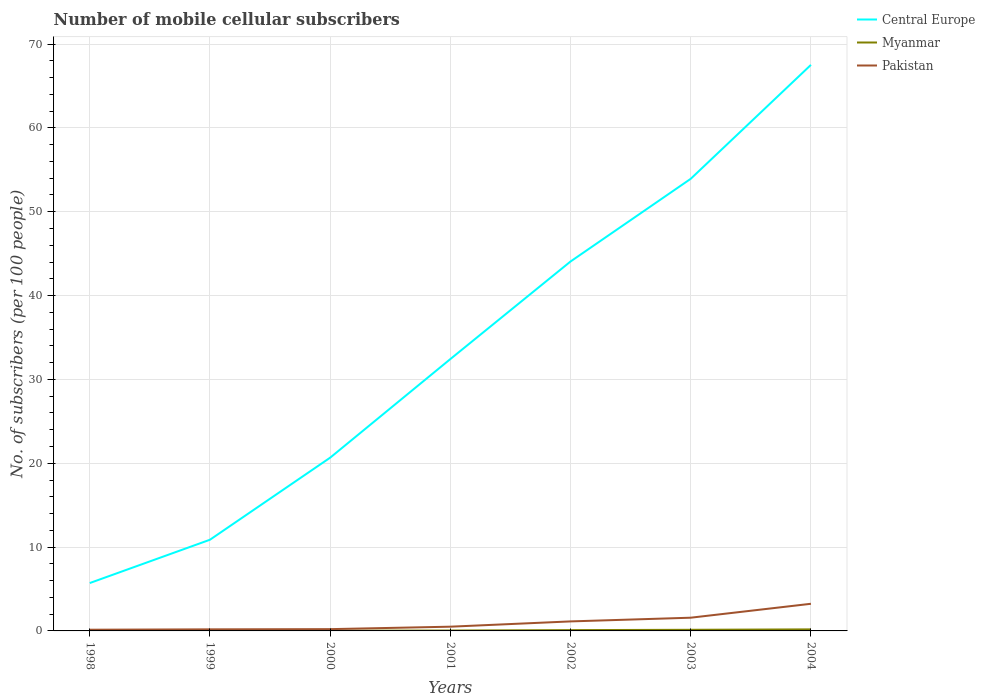Across all years, what is the maximum number of mobile cellular subscribers in Central Europe?
Offer a very short reply. 5.71. In which year was the number of mobile cellular subscribers in Pakistan maximum?
Ensure brevity in your answer.  1998. What is the total number of mobile cellular subscribers in Central Europe in the graph?
Offer a very short reply. -21.55. What is the difference between the highest and the second highest number of mobile cellular subscribers in Central Europe?
Provide a short and direct response. 61.81. Does the graph contain any zero values?
Offer a terse response. No. Does the graph contain grids?
Ensure brevity in your answer.  Yes. Where does the legend appear in the graph?
Provide a succinct answer. Top right. What is the title of the graph?
Your answer should be compact. Number of mobile cellular subscribers. Does "Czech Republic" appear as one of the legend labels in the graph?
Ensure brevity in your answer.  No. What is the label or title of the X-axis?
Ensure brevity in your answer.  Years. What is the label or title of the Y-axis?
Ensure brevity in your answer.  No. of subscribers (per 100 people). What is the No. of subscribers (per 100 people) of Central Europe in 1998?
Your answer should be very brief. 5.71. What is the No. of subscribers (per 100 people) of Myanmar in 1998?
Make the answer very short. 0.02. What is the No. of subscribers (per 100 people) of Pakistan in 1998?
Your answer should be compact. 0.14. What is the No. of subscribers (per 100 people) of Central Europe in 1999?
Your response must be concise. 10.88. What is the No. of subscribers (per 100 people) in Myanmar in 1999?
Offer a terse response. 0.02. What is the No. of subscribers (per 100 people) of Pakistan in 1999?
Make the answer very short. 0.19. What is the No. of subscribers (per 100 people) in Central Europe in 2000?
Offer a very short reply. 20.66. What is the No. of subscribers (per 100 people) in Myanmar in 2000?
Ensure brevity in your answer.  0.03. What is the No. of subscribers (per 100 people) of Pakistan in 2000?
Give a very brief answer. 0.21. What is the No. of subscribers (per 100 people) of Central Europe in 2001?
Give a very brief answer. 32.43. What is the No. of subscribers (per 100 people) in Myanmar in 2001?
Give a very brief answer. 0.05. What is the No. of subscribers (per 100 people) in Pakistan in 2001?
Your answer should be compact. 0.51. What is the No. of subscribers (per 100 people) of Central Europe in 2002?
Make the answer very short. 44.07. What is the No. of subscribers (per 100 people) of Myanmar in 2002?
Offer a terse response. 0.1. What is the No. of subscribers (per 100 people) of Pakistan in 2002?
Your answer should be compact. 1.13. What is the No. of subscribers (per 100 people) of Central Europe in 2003?
Give a very brief answer. 53.93. What is the No. of subscribers (per 100 people) of Myanmar in 2003?
Your answer should be compact. 0.13. What is the No. of subscribers (per 100 people) of Pakistan in 2003?
Keep it short and to the point. 1.58. What is the No. of subscribers (per 100 people) in Central Europe in 2004?
Make the answer very short. 67.52. What is the No. of subscribers (per 100 people) in Myanmar in 2004?
Make the answer very short. 0.19. What is the No. of subscribers (per 100 people) of Pakistan in 2004?
Ensure brevity in your answer.  3.24. Across all years, what is the maximum No. of subscribers (per 100 people) of Central Europe?
Offer a very short reply. 67.52. Across all years, what is the maximum No. of subscribers (per 100 people) in Myanmar?
Ensure brevity in your answer.  0.19. Across all years, what is the maximum No. of subscribers (per 100 people) in Pakistan?
Give a very brief answer. 3.24. Across all years, what is the minimum No. of subscribers (per 100 people) of Central Europe?
Keep it short and to the point. 5.71. Across all years, what is the minimum No. of subscribers (per 100 people) in Myanmar?
Keep it short and to the point. 0.02. Across all years, what is the minimum No. of subscribers (per 100 people) of Pakistan?
Make the answer very short. 0.14. What is the total No. of subscribers (per 100 people) of Central Europe in the graph?
Offer a terse response. 235.2. What is the total No. of subscribers (per 100 people) of Myanmar in the graph?
Your answer should be very brief. 0.53. What is the total No. of subscribers (per 100 people) in Pakistan in the graph?
Make the answer very short. 7. What is the difference between the No. of subscribers (per 100 people) of Central Europe in 1998 and that in 1999?
Provide a short and direct response. -5.17. What is the difference between the No. of subscribers (per 100 people) in Myanmar in 1998 and that in 1999?
Give a very brief answer. -0.01. What is the difference between the No. of subscribers (per 100 people) of Pakistan in 1998 and that in 1999?
Provide a short and direct response. -0.05. What is the difference between the No. of subscribers (per 100 people) in Central Europe in 1998 and that in 2000?
Offer a terse response. -14.95. What is the difference between the No. of subscribers (per 100 people) in Myanmar in 1998 and that in 2000?
Make the answer very short. -0.01. What is the difference between the No. of subscribers (per 100 people) in Pakistan in 1998 and that in 2000?
Provide a succinct answer. -0.07. What is the difference between the No. of subscribers (per 100 people) of Central Europe in 1998 and that in 2001?
Make the answer very short. -26.72. What is the difference between the No. of subscribers (per 100 people) in Myanmar in 1998 and that in 2001?
Your response must be concise. -0.03. What is the difference between the No. of subscribers (per 100 people) of Pakistan in 1998 and that in 2001?
Provide a short and direct response. -0.36. What is the difference between the No. of subscribers (per 100 people) in Central Europe in 1998 and that in 2002?
Provide a short and direct response. -38.36. What is the difference between the No. of subscribers (per 100 people) of Myanmar in 1998 and that in 2002?
Your answer should be very brief. -0.08. What is the difference between the No. of subscribers (per 100 people) of Pakistan in 1998 and that in 2002?
Your answer should be compact. -0.99. What is the difference between the No. of subscribers (per 100 people) of Central Europe in 1998 and that in 2003?
Offer a terse response. -48.22. What is the difference between the No. of subscribers (per 100 people) in Myanmar in 1998 and that in 2003?
Provide a succinct answer. -0.12. What is the difference between the No. of subscribers (per 100 people) of Pakistan in 1998 and that in 2003?
Your answer should be very brief. -1.43. What is the difference between the No. of subscribers (per 100 people) of Central Europe in 1998 and that in 2004?
Provide a succinct answer. -61.81. What is the difference between the No. of subscribers (per 100 people) in Myanmar in 1998 and that in 2004?
Your response must be concise. -0.17. What is the difference between the No. of subscribers (per 100 people) of Pakistan in 1998 and that in 2004?
Provide a short and direct response. -3.09. What is the difference between the No. of subscribers (per 100 people) in Central Europe in 1999 and that in 2000?
Ensure brevity in your answer.  -9.79. What is the difference between the No. of subscribers (per 100 people) of Myanmar in 1999 and that in 2000?
Your answer should be compact. -0. What is the difference between the No. of subscribers (per 100 people) of Pakistan in 1999 and that in 2000?
Keep it short and to the point. -0.02. What is the difference between the No. of subscribers (per 100 people) of Central Europe in 1999 and that in 2001?
Offer a terse response. -21.55. What is the difference between the No. of subscribers (per 100 people) of Myanmar in 1999 and that in 2001?
Your response must be concise. -0.02. What is the difference between the No. of subscribers (per 100 people) of Pakistan in 1999 and that in 2001?
Provide a succinct answer. -0.32. What is the difference between the No. of subscribers (per 100 people) in Central Europe in 1999 and that in 2002?
Give a very brief answer. -33.19. What is the difference between the No. of subscribers (per 100 people) of Myanmar in 1999 and that in 2002?
Ensure brevity in your answer.  -0.07. What is the difference between the No. of subscribers (per 100 people) of Pakistan in 1999 and that in 2002?
Keep it short and to the point. -0.95. What is the difference between the No. of subscribers (per 100 people) in Central Europe in 1999 and that in 2003?
Keep it short and to the point. -43.05. What is the difference between the No. of subscribers (per 100 people) of Myanmar in 1999 and that in 2003?
Offer a terse response. -0.11. What is the difference between the No. of subscribers (per 100 people) of Pakistan in 1999 and that in 2003?
Provide a succinct answer. -1.39. What is the difference between the No. of subscribers (per 100 people) of Central Europe in 1999 and that in 2004?
Provide a succinct answer. -56.64. What is the difference between the No. of subscribers (per 100 people) in Myanmar in 1999 and that in 2004?
Provide a succinct answer. -0.16. What is the difference between the No. of subscribers (per 100 people) of Pakistan in 1999 and that in 2004?
Ensure brevity in your answer.  -3.05. What is the difference between the No. of subscribers (per 100 people) in Central Europe in 2000 and that in 2001?
Provide a short and direct response. -11.76. What is the difference between the No. of subscribers (per 100 people) in Myanmar in 2000 and that in 2001?
Provide a succinct answer. -0.02. What is the difference between the No. of subscribers (per 100 people) in Pakistan in 2000 and that in 2001?
Ensure brevity in your answer.  -0.29. What is the difference between the No. of subscribers (per 100 people) of Central Europe in 2000 and that in 2002?
Your answer should be compact. -23.4. What is the difference between the No. of subscribers (per 100 people) of Myanmar in 2000 and that in 2002?
Ensure brevity in your answer.  -0.07. What is the difference between the No. of subscribers (per 100 people) of Pakistan in 2000 and that in 2002?
Offer a terse response. -0.92. What is the difference between the No. of subscribers (per 100 people) in Central Europe in 2000 and that in 2003?
Offer a terse response. -33.27. What is the difference between the No. of subscribers (per 100 people) of Myanmar in 2000 and that in 2003?
Ensure brevity in your answer.  -0.11. What is the difference between the No. of subscribers (per 100 people) of Pakistan in 2000 and that in 2003?
Your response must be concise. -1.36. What is the difference between the No. of subscribers (per 100 people) of Central Europe in 2000 and that in 2004?
Your answer should be very brief. -46.85. What is the difference between the No. of subscribers (per 100 people) of Myanmar in 2000 and that in 2004?
Your answer should be very brief. -0.16. What is the difference between the No. of subscribers (per 100 people) of Pakistan in 2000 and that in 2004?
Give a very brief answer. -3.02. What is the difference between the No. of subscribers (per 100 people) in Central Europe in 2001 and that in 2002?
Make the answer very short. -11.64. What is the difference between the No. of subscribers (per 100 people) of Myanmar in 2001 and that in 2002?
Make the answer very short. -0.05. What is the difference between the No. of subscribers (per 100 people) of Pakistan in 2001 and that in 2002?
Keep it short and to the point. -0.63. What is the difference between the No. of subscribers (per 100 people) in Central Europe in 2001 and that in 2003?
Your response must be concise. -21.5. What is the difference between the No. of subscribers (per 100 people) in Myanmar in 2001 and that in 2003?
Keep it short and to the point. -0.09. What is the difference between the No. of subscribers (per 100 people) in Pakistan in 2001 and that in 2003?
Offer a very short reply. -1.07. What is the difference between the No. of subscribers (per 100 people) of Central Europe in 2001 and that in 2004?
Offer a terse response. -35.09. What is the difference between the No. of subscribers (per 100 people) in Myanmar in 2001 and that in 2004?
Your answer should be compact. -0.14. What is the difference between the No. of subscribers (per 100 people) of Pakistan in 2001 and that in 2004?
Your answer should be very brief. -2.73. What is the difference between the No. of subscribers (per 100 people) in Central Europe in 2002 and that in 2003?
Your answer should be compact. -9.86. What is the difference between the No. of subscribers (per 100 people) in Myanmar in 2002 and that in 2003?
Offer a terse response. -0.04. What is the difference between the No. of subscribers (per 100 people) of Pakistan in 2002 and that in 2003?
Offer a terse response. -0.44. What is the difference between the No. of subscribers (per 100 people) in Central Europe in 2002 and that in 2004?
Give a very brief answer. -23.45. What is the difference between the No. of subscribers (per 100 people) of Myanmar in 2002 and that in 2004?
Give a very brief answer. -0.09. What is the difference between the No. of subscribers (per 100 people) in Pakistan in 2002 and that in 2004?
Ensure brevity in your answer.  -2.1. What is the difference between the No. of subscribers (per 100 people) in Central Europe in 2003 and that in 2004?
Your answer should be compact. -13.59. What is the difference between the No. of subscribers (per 100 people) of Myanmar in 2003 and that in 2004?
Make the answer very short. -0.05. What is the difference between the No. of subscribers (per 100 people) in Pakistan in 2003 and that in 2004?
Your response must be concise. -1.66. What is the difference between the No. of subscribers (per 100 people) of Central Europe in 1998 and the No. of subscribers (per 100 people) of Myanmar in 1999?
Provide a succinct answer. 5.69. What is the difference between the No. of subscribers (per 100 people) of Central Europe in 1998 and the No. of subscribers (per 100 people) of Pakistan in 1999?
Your answer should be compact. 5.52. What is the difference between the No. of subscribers (per 100 people) in Myanmar in 1998 and the No. of subscribers (per 100 people) in Pakistan in 1999?
Make the answer very short. -0.17. What is the difference between the No. of subscribers (per 100 people) in Central Europe in 1998 and the No. of subscribers (per 100 people) in Myanmar in 2000?
Provide a short and direct response. 5.68. What is the difference between the No. of subscribers (per 100 people) of Central Europe in 1998 and the No. of subscribers (per 100 people) of Pakistan in 2000?
Ensure brevity in your answer.  5.5. What is the difference between the No. of subscribers (per 100 people) of Myanmar in 1998 and the No. of subscribers (per 100 people) of Pakistan in 2000?
Offer a terse response. -0.2. What is the difference between the No. of subscribers (per 100 people) in Central Europe in 1998 and the No. of subscribers (per 100 people) in Myanmar in 2001?
Your answer should be very brief. 5.66. What is the difference between the No. of subscribers (per 100 people) of Central Europe in 1998 and the No. of subscribers (per 100 people) of Pakistan in 2001?
Ensure brevity in your answer.  5.2. What is the difference between the No. of subscribers (per 100 people) in Myanmar in 1998 and the No. of subscribers (per 100 people) in Pakistan in 2001?
Ensure brevity in your answer.  -0.49. What is the difference between the No. of subscribers (per 100 people) of Central Europe in 1998 and the No. of subscribers (per 100 people) of Myanmar in 2002?
Make the answer very short. 5.61. What is the difference between the No. of subscribers (per 100 people) of Central Europe in 1998 and the No. of subscribers (per 100 people) of Pakistan in 2002?
Provide a succinct answer. 4.58. What is the difference between the No. of subscribers (per 100 people) of Myanmar in 1998 and the No. of subscribers (per 100 people) of Pakistan in 2002?
Keep it short and to the point. -1.12. What is the difference between the No. of subscribers (per 100 people) in Central Europe in 1998 and the No. of subscribers (per 100 people) in Myanmar in 2003?
Make the answer very short. 5.58. What is the difference between the No. of subscribers (per 100 people) of Central Europe in 1998 and the No. of subscribers (per 100 people) of Pakistan in 2003?
Your answer should be very brief. 4.13. What is the difference between the No. of subscribers (per 100 people) of Myanmar in 1998 and the No. of subscribers (per 100 people) of Pakistan in 2003?
Provide a succinct answer. -1.56. What is the difference between the No. of subscribers (per 100 people) of Central Europe in 1998 and the No. of subscribers (per 100 people) of Myanmar in 2004?
Offer a very short reply. 5.53. What is the difference between the No. of subscribers (per 100 people) in Central Europe in 1998 and the No. of subscribers (per 100 people) in Pakistan in 2004?
Keep it short and to the point. 2.47. What is the difference between the No. of subscribers (per 100 people) of Myanmar in 1998 and the No. of subscribers (per 100 people) of Pakistan in 2004?
Make the answer very short. -3.22. What is the difference between the No. of subscribers (per 100 people) of Central Europe in 1999 and the No. of subscribers (per 100 people) of Myanmar in 2000?
Provide a succinct answer. 10.85. What is the difference between the No. of subscribers (per 100 people) of Central Europe in 1999 and the No. of subscribers (per 100 people) of Pakistan in 2000?
Offer a very short reply. 10.66. What is the difference between the No. of subscribers (per 100 people) in Myanmar in 1999 and the No. of subscribers (per 100 people) in Pakistan in 2000?
Keep it short and to the point. -0.19. What is the difference between the No. of subscribers (per 100 people) in Central Europe in 1999 and the No. of subscribers (per 100 people) in Myanmar in 2001?
Give a very brief answer. 10.83. What is the difference between the No. of subscribers (per 100 people) in Central Europe in 1999 and the No. of subscribers (per 100 people) in Pakistan in 2001?
Make the answer very short. 10.37. What is the difference between the No. of subscribers (per 100 people) in Myanmar in 1999 and the No. of subscribers (per 100 people) in Pakistan in 2001?
Your answer should be very brief. -0.48. What is the difference between the No. of subscribers (per 100 people) in Central Europe in 1999 and the No. of subscribers (per 100 people) in Myanmar in 2002?
Your answer should be very brief. 10.78. What is the difference between the No. of subscribers (per 100 people) of Central Europe in 1999 and the No. of subscribers (per 100 people) of Pakistan in 2002?
Make the answer very short. 9.74. What is the difference between the No. of subscribers (per 100 people) of Myanmar in 1999 and the No. of subscribers (per 100 people) of Pakistan in 2002?
Give a very brief answer. -1.11. What is the difference between the No. of subscribers (per 100 people) of Central Europe in 1999 and the No. of subscribers (per 100 people) of Myanmar in 2003?
Make the answer very short. 10.74. What is the difference between the No. of subscribers (per 100 people) of Central Europe in 1999 and the No. of subscribers (per 100 people) of Pakistan in 2003?
Your answer should be very brief. 9.3. What is the difference between the No. of subscribers (per 100 people) in Myanmar in 1999 and the No. of subscribers (per 100 people) in Pakistan in 2003?
Provide a short and direct response. -1.55. What is the difference between the No. of subscribers (per 100 people) in Central Europe in 1999 and the No. of subscribers (per 100 people) in Myanmar in 2004?
Make the answer very short. 10.69. What is the difference between the No. of subscribers (per 100 people) of Central Europe in 1999 and the No. of subscribers (per 100 people) of Pakistan in 2004?
Your answer should be compact. 7.64. What is the difference between the No. of subscribers (per 100 people) in Myanmar in 1999 and the No. of subscribers (per 100 people) in Pakistan in 2004?
Provide a short and direct response. -3.21. What is the difference between the No. of subscribers (per 100 people) in Central Europe in 2000 and the No. of subscribers (per 100 people) in Myanmar in 2001?
Provide a short and direct response. 20.62. What is the difference between the No. of subscribers (per 100 people) in Central Europe in 2000 and the No. of subscribers (per 100 people) in Pakistan in 2001?
Give a very brief answer. 20.16. What is the difference between the No. of subscribers (per 100 people) of Myanmar in 2000 and the No. of subscribers (per 100 people) of Pakistan in 2001?
Your answer should be very brief. -0.48. What is the difference between the No. of subscribers (per 100 people) of Central Europe in 2000 and the No. of subscribers (per 100 people) of Myanmar in 2002?
Ensure brevity in your answer.  20.57. What is the difference between the No. of subscribers (per 100 people) in Central Europe in 2000 and the No. of subscribers (per 100 people) in Pakistan in 2002?
Keep it short and to the point. 19.53. What is the difference between the No. of subscribers (per 100 people) of Myanmar in 2000 and the No. of subscribers (per 100 people) of Pakistan in 2002?
Your answer should be very brief. -1.11. What is the difference between the No. of subscribers (per 100 people) of Central Europe in 2000 and the No. of subscribers (per 100 people) of Myanmar in 2003?
Your answer should be compact. 20.53. What is the difference between the No. of subscribers (per 100 people) of Central Europe in 2000 and the No. of subscribers (per 100 people) of Pakistan in 2003?
Keep it short and to the point. 19.09. What is the difference between the No. of subscribers (per 100 people) in Myanmar in 2000 and the No. of subscribers (per 100 people) in Pakistan in 2003?
Ensure brevity in your answer.  -1.55. What is the difference between the No. of subscribers (per 100 people) of Central Europe in 2000 and the No. of subscribers (per 100 people) of Myanmar in 2004?
Offer a very short reply. 20.48. What is the difference between the No. of subscribers (per 100 people) in Central Europe in 2000 and the No. of subscribers (per 100 people) in Pakistan in 2004?
Provide a short and direct response. 17.43. What is the difference between the No. of subscribers (per 100 people) of Myanmar in 2000 and the No. of subscribers (per 100 people) of Pakistan in 2004?
Provide a short and direct response. -3.21. What is the difference between the No. of subscribers (per 100 people) of Central Europe in 2001 and the No. of subscribers (per 100 people) of Myanmar in 2002?
Offer a terse response. 32.33. What is the difference between the No. of subscribers (per 100 people) of Central Europe in 2001 and the No. of subscribers (per 100 people) of Pakistan in 2002?
Offer a terse response. 31.29. What is the difference between the No. of subscribers (per 100 people) in Myanmar in 2001 and the No. of subscribers (per 100 people) in Pakistan in 2002?
Offer a very short reply. -1.09. What is the difference between the No. of subscribers (per 100 people) in Central Europe in 2001 and the No. of subscribers (per 100 people) in Myanmar in 2003?
Make the answer very short. 32.29. What is the difference between the No. of subscribers (per 100 people) in Central Europe in 2001 and the No. of subscribers (per 100 people) in Pakistan in 2003?
Ensure brevity in your answer.  30.85. What is the difference between the No. of subscribers (per 100 people) of Myanmar in 2001 and the No. of subscribers (per 100 people) of Pakistan in 2003?
Ensure brevity in your answer.  -1.53. What is the difference between the No. of subscribers (per 100 people) of Central Europe in 2001 and the No. of subscribers (per 100 people) of Myanmar in 2004?
Provide a succinct answer. 32.24. What is the difference between the No. of subscribers (per 100 people) of Central Europe in 2001 and the No. of subscribers (per 100 people) of Pakistan in 2004?
Provide a succinct answer. 29.19. What is the difference between the No. of subscribers (per 100 people) in Myanmar in 2001 and the No. of subscribers (per 100 people) in Pakistan in 2004?
Provide a succinct answer. -3.19. What is the difference between the No. of subscribers (per 100 people) in Central Europe in 2002 and the No. of subscribers (per 100 people) in Myanmar in 2003?
Keep it short and to the point. 43.93. What is the difference between the No. of subscribers (per 100 people) in Central Europe in 2002 and the No. of subscribers (per 100 people) in Pakistan in 2003?
Give a very brief answer. 42.49. What is the difference between the No. of subscribers (per 100 people) of Myanmar in 2002 and the No. of subscribers (per 100 people) of Pakistan in 2003?
Your response must be concise. -1.48. What is the difference between the No. of subscribers (per 100 people) of Central Europe in 2002 and the No. of subscribers (per 100 people) of Myanmar in 2004?
Offer a terse response. 43.88. What is the difference between the No. of subscribers (per 100 people) of Central Europe in 2002 and the No. of subscribers (per 100 people) of Pakistan in 2004?
Provide a short and direct response. 40.83. What is the difference between the No. of subscribers (per 100 people) in Myanmar in 2002 and the No. of subscribers (per 100 people) in Pakistan in 2004?
Offer a terse response. -3.14. What is the difference between the No. of subscribers (per 100 people) of Central Europe in 2003 and the No. of subscribers (per 100 people) of Myanmar in 2004?
Give a very brief answer. 53.75. What is the difference between the No. of subscribers (per 100 people) in Central Europe in 2003 and the No. of subscribers (per 100 people) in Pakistan in 2004?
Provide a succinct answer. 50.69. What is the difference between the No. of subscribers (per 100 people) of Myanmar in 2003 and the No. of subscribers (per 100 people) of Pakistan in 2004?
Provide a succinct answer. -3.1. What is the average No. of subscribers (per 100 people) in Central Europe per year?
Your answer should be compact. 33.6. What is the average No. of subscribers (per 100 people) of Myanmar per year?
Offer a terse response. 0.08. In the year 1998, what is the difference between the No. of subscribers (per 100 people) of Central Europe and No. of subscribers (per 100 people) of Myanmar?
Offer a terse response. 5.69. In the year 1998, what is the difference between the No. of subscribers (per 100 people) in Central Europe and No. of subscribers (per 100 people) in Pakistan?
Provide a short and direct response. 5.57. In the year 1998, what is the difference between the No. of subscribers (per 100 people) of Myanmar and No. of subscribers (per 100 people) of Pakistan?
Ensure brevity in your answer.  -0.12. In the year 1999, what is the difference between the No. of subscribers (per 100 people) in Central Europe and No. of subscribers (per 100 people) in Myanmar?
Your response must be concise. 10.85. In the year 1999, what is the difference between the No. of subscribers (per 100 people) in Central Europe and No. of subscribers (per 100 people) in Pakistan?
Provide a short and direct response. 10.69. In the year 1999, what is the difference between the No. of subscribers (per 100 people) in Myanmar and No. of subscribers (per 100 people) in Pakistan?
Make the answer very short. -0.17. In the year 2000, what is the difference between the No. of subscribers (per 100 people) of Central Europe and No. of subscribers (per 100 people) of Myanmar?
Give a very brief answer. 20.64. In the year 2000, what is the difference between the No. of subscribers (per 100 people) in Central Europe and No. of subscribers (per 100 people) in Pakistan?
Your answer should be very brief. 20.45. In the year 2000, what is the difference between the No. of subscribers (per 100 people) of Myanmar and No. of subscribers (per 100 people) of Pakistan?
Make the answer very short. -0.19. In the year 2001, what is the difference between the No. of subscribers (per 100 people) in Central Europe and No. of subscribers (per 100 people) in Myanmar?
Make the answer very short. 32.38. In the year 2001, what is the difference between the No. of subscribers (per 100 people) of Central Europe and No. of subscribers (per 100 people) of Pakistan?
Your answer should be very brief. 31.92. In the year 2001, what is the difference between the No. of subscribers (per 100 people) in Myanmar and No. of subscribers (per 100 people) in Pakistan?
Keep it short and to the point. -0.46. In the year 2002, what is the difference between the No. of subscribers (per 100 people) of Central Europe and No. of subscribers (per 100 people) of Myanmar?
Offer a terse response. 43.97. In the year 2002, what is the difference between the No. of subscribers (per 100 people) in Central Europe and No. of subscribers (per 100 people) in Pakistan?
Give a very brief answer. 42.93. In the year 2002, what is the difference between the No. of subscribers (per 100 people) of Myanmar and No. of subscribers (per 100 people) of Pakistan?
Ensure brevity in your answer.  -1.04. In the year 2003, what is the difference between the No. of subscribers (per 100 people) of Central Europe and No. of subscribers (per 100 people) of Myanmar?
Your answer should be very brief. 53.8. In the year 2003, what is the difference between the No. of subscribers (per 100 people) in Central Europe and No. of subscribers (per 100 people) in Pakistan?
Offer a very short reply. 52.35. In the year 2003, what is the difference between the No. of subscribers (per 100 people) in Myanmar and No. of subscribers (per 100 people) in Pakistan?
Give a very brief answer. -1.44. In the year 2004, what is the difference between the No. of subscribers (per 100 people) of Central Europe and No. of subscribers (per 100 people) of Myanmar?
Offer a terse response. 67.33. In the year 2004, what is the difference between the No. of subscribers (per 100 people) in Central Europe and No. of subscribers (per 100 people) in Pakistan?
Your answer should be compact. 64.28. In the year 2004, what is the difference between the No. of subscribers (per 100 people) of Myanmar and No. of subscribers (per 100 people) of Pakistan?
Your answer should be very brief. -3.05. What is the ratio of the No. of subscribers (per 100 people) in Central Europe in 1998 to that in 1999?
Your response must be concise. 0.53. What is the ratio of the No. of subscribers (per 100 people) of Myanmar in 1998 to that in 1999?
Keep it short and to the point. 0.76. What is the ratio of the No. of subscribers (per 100 people) of Pakistan in 1998 to that in 1999?
Ensure brevity in your answer.  0.76. What is the ratio of the No. of subscribers (per 100 people) in Central Europe in 1998 to that in 2000?
Make the answer very short. 0.28. What is the ratio of the No. of subscribers (per 100 people) of Myanmar in 1998 to that in 2000?
Your response must be concise. 0.65. What is the ratio of the No. of subscribers (per 100 people) of Pakistan in 1998 to that in 2000?
Keep it short and to the point. 0.67. What is the ratio of the No. of subscribers (per 100 people) in Central Europe in 1998 to that in 2001?
Ensure brevity in your answer.  0.18. What is the ratio of the No. of subscribers (per 100 people) in Myanmar in 1998 to that in 2001?
Keep it short and to the point. 0.39. What is the ratio of the No. of subscribers (per 100 people) of Pakistan in 1998 to that in 2001?
Offer a very short reply. 0.28. What is the ratio of the No. of subscribers (per 100 people) in Central Europe in 1998 to that in 2002?
Provide a short and direct response. 0.13. What is the ratio of the No. of subscribers (per 100 people) in Myanmar in 1998 to that in 2002?
Keep it short and to the point. 0.18. What is the ratio of the No. of subscribers (per 100 people) of Pakistan in 1998 to that in 2002?
Your response must be concise. 0.13. What is the ratio of the No. of subscribers (per 100 people) of Central Europe in 1998 to that in 2003?
Keep it short and to the point. 0.11. What is the ratio of the No. of subscribers (per 100 people) of Myanmar in 1998 to that in 2003?
Make the answer very short. 0.13. What is the ratio of the No. of subscribers (per 100 people) in Pakistan in 1998 to that in 2003?
Provide a short and direct response. 0.09. What is the ratio of the No. of subscribers (per 100 people) of Central Europe in 1998 to that in 2004?
Make the answer very short. 0.08. What is the ratio of the No. of subscribers (per 100 people) of Myanmar in 1998 to that in 2004?
Keep it short and to the point. 0.1. What is the ratio of the No. of subscribers (per 100 people) of Pakistan in 1998 to that in 2004?
Offer a terse response. 0.04. What is the ratio of the No. of subscribers (per 100 people) in Central Europe in 1999 to that in 2000?
Give a very brief answer. 0.53. What is the ratio of the No. of subscribers (per 100 people) in Myanmar in 1999 to that in 2000?
Your response must be concise. 0.86. What is the ratio of the No. of subscribers (per 100 people) of Pakistan in 1999 to that in 2000?
Provide a succinct answer. 0.89. What is the ratio of the No. of subscribers (per 100 people) of Central Europe in 1999 to that in 2001?
Make the answer very short. 0.34. What is the ratio of the No. of subscribers (per 100 people) in Myanmar in 1999 to that in 2001?
Keep it short and to the point. 0.51. What is the ratio of the No. of subscribers (per 100 people) of Pakistan in 1999 to that in 2001?
Offer a terse response. 0.37. What is the ratio of the No. of subscribers (per 100 people) of Central Europe in 1999 to that in 2002?
Offer a very short reply. 0.25. What is the ratio of the No. of subscribers (per 100 people) in Myanmar in 1999 to that in 2002?
Keep it short and to the point. 0.24. What is the ratio of the No. of subscribers (per 100 people) of Pakistan in 1999 to that in 2002?
Provide a succinct answer. 0.17. What is the ratio of the No. of subscribers (per 100 people) in Central Europe in 1999 to that in 2003?
Make the answer very short. 0.2. What is the ratio of the No. of subscribers (per 100 people) in Myanmar in 1999 to that in 2003?
Ensure brevity in your answer.  0.18. What is the ratio of the No. of subscribers (per 100 people) in Pakistan in 1999 to that in 2003?
Provide a succinct answer. 0.12. What is the ratio of the No. of subscribers (per 100 people) of Central Europe in 1999 to that in 2004?
Provide a short and direct response. 0.16. What is the ratio of the No. of subscribers (per 100 people) of Myanmar in 1999 to that in 2004?
Ensure brevity in your answer.  0.13. What is the ratio of the No. of subscribers (per 100 people) of Pakistan in 1999 to that in 2004?
Ensure brevity in your answer.  0.06. What is the ratio of the No. of subscribers (per 100 people) of Central Europe in 2000 to that in 2001?
Your response must be concise. 0.64. What is the ratio of the No. of subscribers (per 100 people) of Myanmar in 2000 to that in 2001?
Provide a succinct answer. 0.6. What is the ratio of the No. of subscribers (per 100 people) in Pakistan in 2000 to that in 2001?
Give a very brief answer. 0.42. What is the ratio of the No. of subscribers (per 100 people) of Central Europe in 2000 to that in 2002?
Keep it short and to the point. 0.47. What is the ratio of the No. of subscribers (per 100 people) in Myanmar in 2000 to that in 2002?
Offer a very short reply. 0.28. What is the ratio of the No. of subscribers (per 100 people) in Pakistan in 2000 to that in 2002?
Ensure brevity in your answer.  0.19. What is the ratio of the No. of subscribers (per 100 people) in Central Europe in 2000 to that in 2003?
Provide a succinct answer. 0.38. What is the ratio of the No. of subscribers (per 100 people) in Myanmar in 2000 to that in 2003?
Offer a terse response. 0.21. What is the ratio of the No. of subscribers (per 100 people) of Pakistan in 2000 to that in 2003?
Provide a succinct answer. 0.14. What is the ratio of the No. of subscribers (per 100 people) in Central Europe in 2000 to that in 2004?
Your answer should be compact. 0.31. What is the ratio of the No. of subscribers (per 100 people) in Myanmar in 2000 to that in 2004?
Your answer should be very brief. 0.15. What is the ratio of the No. of subscribers (per 100 people) in Pakistan in 2000 to that in 2004?
Ensure brevity in your answer.  0.07. What is the ratio of the No. of subscribers (per 100 people) in Central Europe in 2001 to that in 2002?
Keep it short and to the point. 0.74. What is the ratio of the No. of subscribers (per 100 people) of Myanmar in 2001 to that in 2002?
Offer a terse response. 0.48. What is the ratio of the No. of subscribers (per 100 people) in Pakistan in 2001 to that in 2002?
Make the answer very short. 0.45. What is the ratio of the No. of subscribers (per 100 people) in Central Europe in 2001 to that in 2003?
Make the answer very short. 0.6. What is the ratio of the No. of subscribers (per 100 people) of Myanmar in 2001 to that in 2003?
Keep it short and to the point. 0.35. What is the ratio of the No. of subscribers (per 100 people) in Pakistan in 2001 to that in 2003?
Offer a very short reply. 0.32. What is the ratio of the No. of subscribers (per 100 people) in Central Europe in 2001 to that in 2004?
Your answer should be compact. 0.48. What is the ratio of the No. of subscribers (per 100 people) in Myanmar in 2001 to that in 2004?
Keep it short and to the point. 0.25. What is the ratio of the No. of subscribers (per 100 people) in Pakistan in 2001 to that in 2004?
Provide a short and direct response. 0.16. What is the ratio of the No. of subscribers (per 100 people) in Central Europe in 2002 to that in 2003?
Make the answer very short. 0.82. What is the ratio of the No. of subscribers (per 100 people) in Myanmar in 2002 to that in 2003?
Your response must be concise. 0.73. What is the ratio of the No. of subscribers (per 100 people) in Pakistan in 2002 to that in 2003?
Offer a very short reply. 0.72. What is the ratio of the No. of subscribers (per 100 people) in Central Europe in 2002 to that in 2004?
Provide a succinct answer. 0.65. What is the ratio of the No. of subscribers (per 100 people) in Myanmar in 2002 to that in 2004?
Your answer should be very brief. 0.53. What is the ratio of the No. of subscribers (per 100 people) of Pakistan in 2002 to that in 2004?
Your answer should be very brief. 0.35. What is the ratio of the No. of subscribers (per 100 people) of Central Europe in 2003 to that in 2004?
Your answer should be compact. 0.8. What is the ratio of the No. of subscribers (per 100 people) of Myanmar in 2003 to that in 2004?
Keep it short and to the point. 0.72. What is the ratio of the No. of subscribers (per 100 people) in Pakistan in 2003 to that in 2004?
Your answer should be compact. 0.49. What is the difference between the highest and the second highest No. of subscribers (per 100 people) of Central Europe?
Keep it short and to the point. 13.59. What is the difference between the highest and the second highest No. of subscribers (per 100 people) of Myanmar?
Your answer should be compact. 0.05. What is the difference between the highest and the second highest No. of subscribers (per 100 people) in Pakistan?
Offer a terse response. 1.66. What is the difference between the highest and the lowest No. of subscribers (per 100 people) in Central Europe?
Give a very brief answer. 61.81. What is the difference between the highest and the lowest No. of subscribers (per 100 people) of Myanmar?
Make the answer very short. 0.17. What is the difference between the highest and the lowest No. of subscribers (per 100 people) of Pakistan?
Make the answer very short. 3.09. 